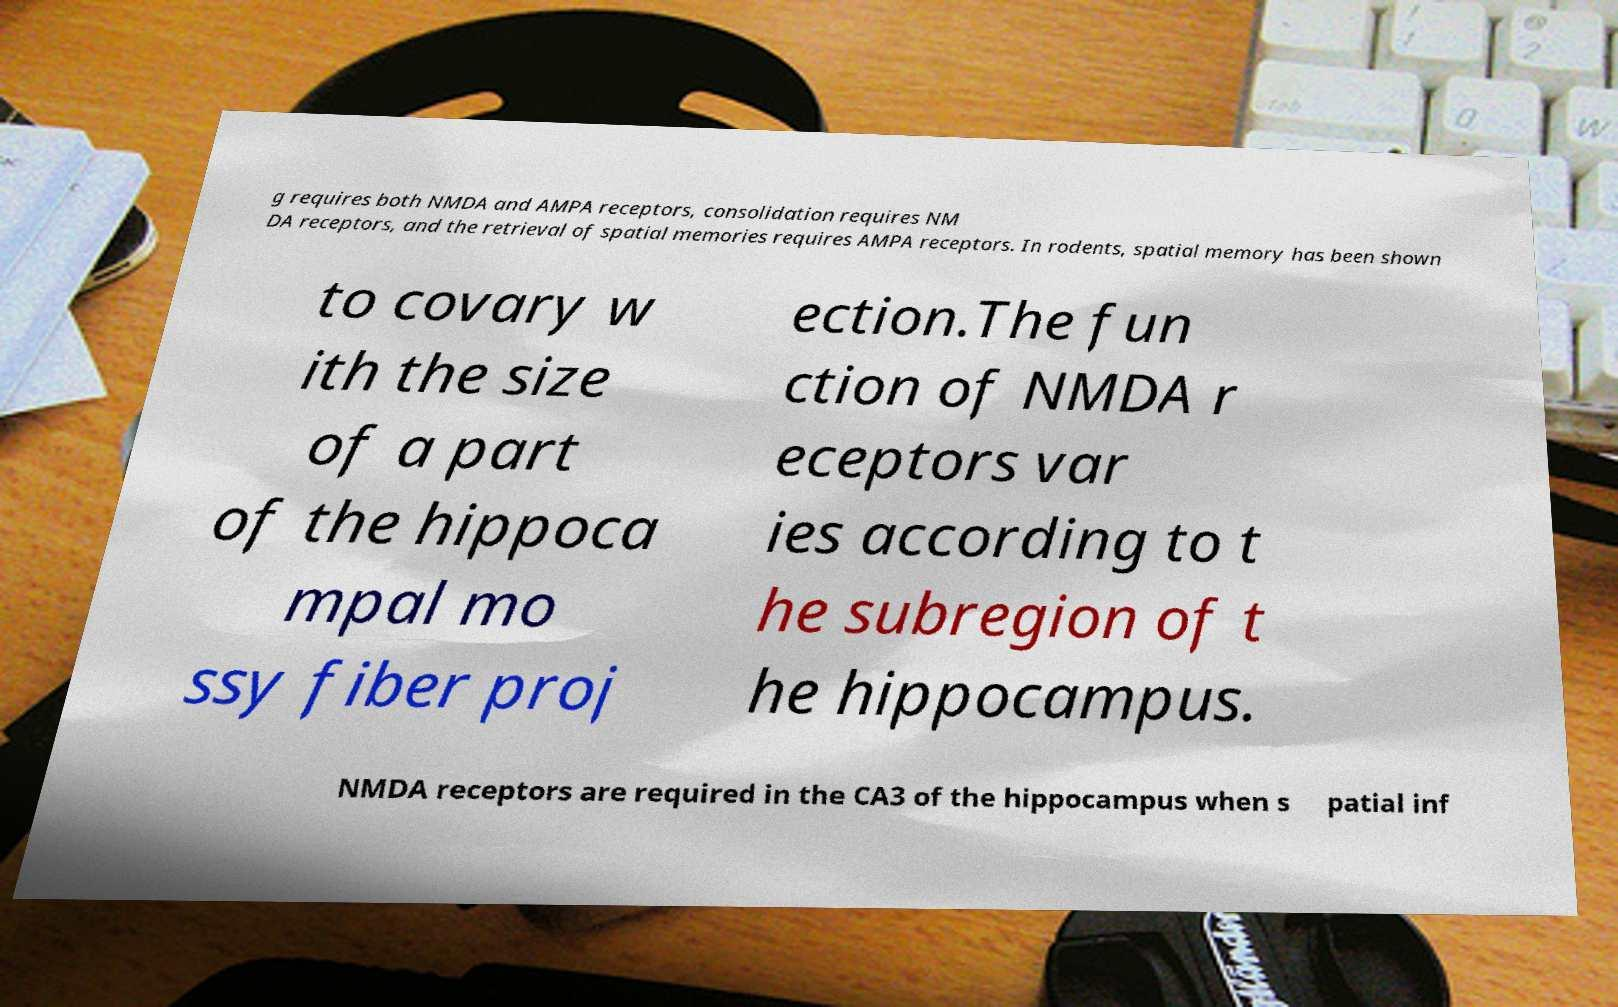I need the written content from this picture converted into text. Can you do that? g requires both NMDA and AMPA receptors, consolidation requires NM DA receptors, and the retrieval of spatial memories requires AMPA receptors. In rodents, spatial memory has been shown to covary w ith the size of a part of the hippoca mpal mo ssy fiber proj ection.The fun ction of NMDA r eceptors var ies according to t he subregion of t he hippocampus. NMDA receptors are required in the CA3 of the hippocampus when s patial inf 